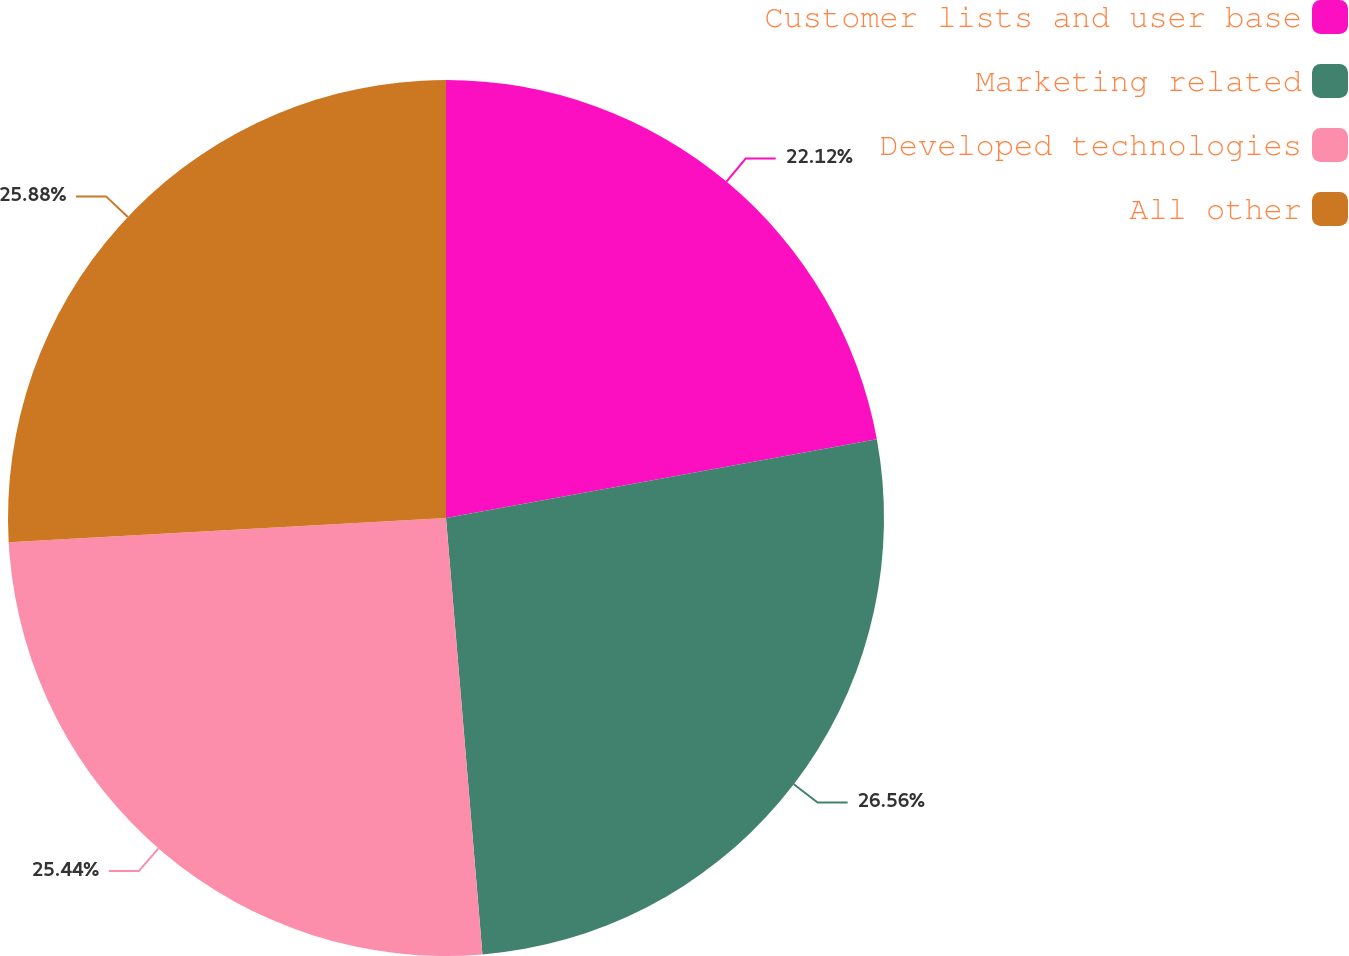<chart> <loc_0><loc_0><loc_500><loc_500><pie_chart><fcel>Customer lists and user base<fcel>Marketing related<fcel>Developed technologies<fcel>All other<nl><fcel>22.12%<fcel>26.55%<fcel>25.44%<fcel>25.88%<nl></chart> 